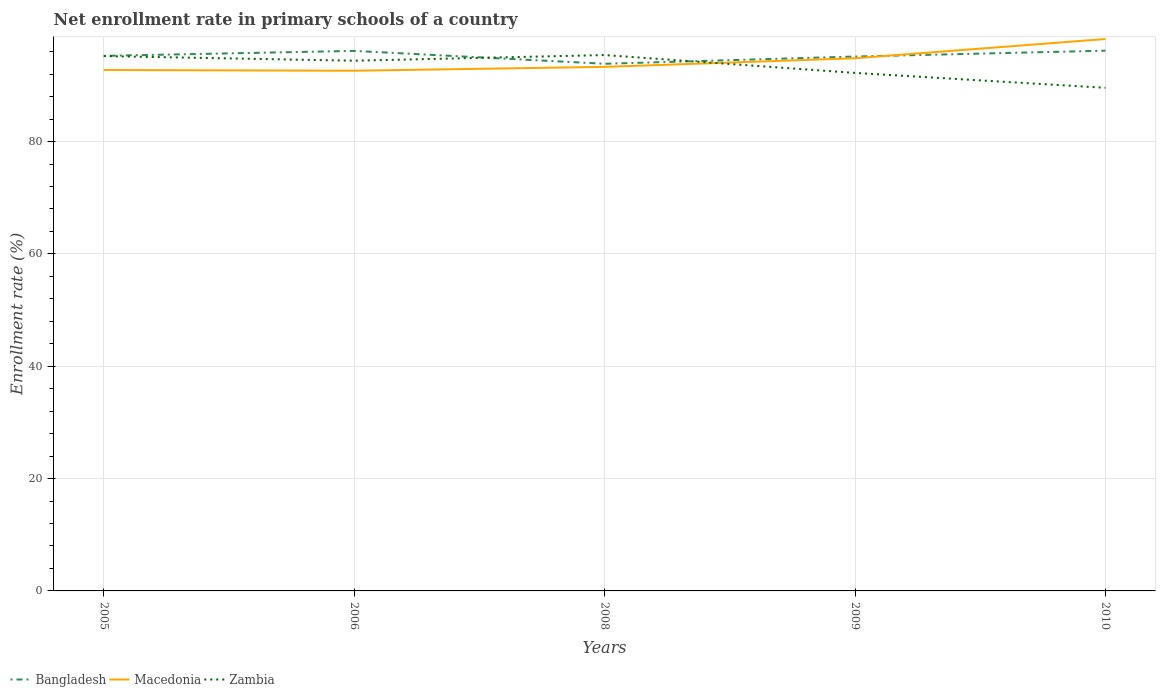Does the line corresponding to Zambia intersect with the line corresponding to Macedonia?
Make the answer very short. Yes. Is the number of lines equal to the number of legend labels?
Your answer should be compact. Yes. Across all years, what is the maximum enrollment rate in primary schools in Zambia?
Your response must be concise. 89.57. In which year was the enrollment rate in primary schools in Macedonia maximum?
Offer a terse response. 2006. What is the total enrollment rate in primary schools in Zambia in the graph?
Your answer should be very brief. 2.65. What is the difference between the highest and the second highest enrollment rate in primary schools in Bangladesh?
Make the answer very short. 2.33. Is the enrollment rate in primary schools in Bangladesh strictly greater than the enrollment rate in primary schools in Zambia over the years?
Your response must be concise. No. How many lines are there?
Provide a short and direct response. 3. How many years are there in the graph?
Give a very brief answer. 5. Are the values on the major ticks of Y-axis written in scientific E-notation?
Your answer should be very brief. No. Does the graph contain any zero values?
Ensure brevity in your answer.  No. Does the graph contain grids?
Your answer should be very brief. Yes. How are the legend labels stacked?
Your answer should be very brief. Horizontal. What is the title of the graph?
Your response must be concise. Net enrollment rate in primary schools of a country. What is the label or title of the X-axis?
Your answer should be very brief. Years. What is the label or title of the Y-axis?
Keep it short and to the point. Enrollment rate (%). What is the Enrollment rate (%) of Bangladesh in 2005?
Your response must be concise. 95.26. What is the Enrollment rate (%) of Macedonia in 2005?
Provide a short and direct response. 92.74. What is the Enrollment rate (%) of Zambia in 2005?
Give a very brief answer. 95.22. What is the Enrollment rate (%) of Bangladesh in 2006?
Your response must be concise. 96.14. What is the Enrollment rate (%) of Macedonia in 2006?
Your response must be concise. 92.61. What is the Enrollment rate (%) of Zambia in 2006?
Your response must be concise. 94.39. What is the Enrollment rate (%) in Bangladesh in 2008?
Keep it short and to the point. 93.85. What is the Enrollment rate (%) of Macedonia in 2008?
Keep it short and to the point. 93.3. What is the Enrollment rate (%) of Zambia in 2008?
Provide a short and direct response. 95.4. What is the Enrollment rate (%) of Bangladesh in 2009?
Offer a very short reply. 95.14. What is the Enrollment rate (%) in Macedonia in 2009?
Your response must be concise. 94.83. What is the Enrollment rate (%) in Zambia in 2009?
Your answer should be very brief. 92.22. What is the Enrollment rate (%) of Bangladesh in 2010?
Provide a short and direct response. 96.18. What is the Enrollment rate (%) of Macedonia in 2010?
Provide a succinct answer. 98.26. What is the Enrollment rate (%) in Zambia in 2010?
Provide a short and direct response. 89.57. Across all years, what is the maximum Enrollment rate (%) of Bangladesh?
Provide a succinct answer. 96.18. Across all years, what is the maximum Enrollment rate (%) of Macedonia?
Your answer should be compact. 98.26. Across all years, what is the maximum Enrollment rate (%) of Zambia?
Give a very brief answer. 95.4. Across all years, what is the minimum Enrollment rate (%) of Bangladesh?
Your answer should be very brief. 93.85. Across all years, what is the minimum Enrollment rate (%) in Macedonia?
Provide a succinct answer. 92.61. Across all years, what is the minimum Enrollment rate (%) in Zambia?
Keep it short and to the point. 89.57. What is the total Enrollment rate (%) of Bangladesh in the graph?
Your answer should be very brief. 476.57. What is the total Enrollment rate (%) in Macedonia in the graph?
Offer a very short reply. 471.74. What is the total Enrollment rate (%) in Zambia in the graph?
Make the answer very short. 466.8. What is the difference between the Enrollment rate (%) in Bangladesh in 2005 and that in 2006?
Keep it short and to the point. -0.89. What is the difference between the Enrollment rate (%) of Macedonia in 2005 and that in 2006?
Keep it short and to the point. 0.13. What is the difference between the Enrollment rate (%) in Zambia in 2005 and that in 2006?
Ensure brevity in your answer.  0.82. What is the difference between the Enrollment rate (%) in Bangladesh in 2005 and that in 2008?
Offer a very short reply. 1.41. What is the difference between the Enrollment rate (%) in Macedonia in 2005 and that in 2008?
Your answer should be very brief. -0.55. What is the difference between the Enrollment rate (%) in Zambia in 2005 and that in 2008?
Keep it short and to the point. -0.18. What is the difference between the Enrollment rate (%) of Bangladesh in 2005 and that in 2009?
Provide a short and direct response. 0.12. What is the difference between the Enrollment rate (%) of Macedonia in 2005 and that in 2009?
Your response must be concise. -2.09. What is the difference between the Enrollment rate (%) of Zambia in 2005 and that in 2009?
Ensure brevity in your answer.  3. What is the difference between the Enrollment rate (%) in Bangladesh in 2005 and that in 2010?
Ensure brevity in your answer.  -0.92. What is the difference between the Enrollment rate (%) of Macedonia in 2005 and that in 2010?
Give a very brief answer. -5.51. What is the difference between the Enrollment rate (%) of Zambia in 2005 and that in 2010?
Make the answer very short. 5.65. What is the difference between the Enrollment rate (%) of Bangladesh in 2006 and that in 2008?
Provide a succinct answer. 2.29. What is the difference between the Enrollment rate (%) in Macedonia in 2006 and that in 2008?
Keep it short and to the point. -0.69. What is the difference between the Enrollment rate (%) of Zambia in 2006 and that in 2008?
Your response must be concise. -1.01. What is the difference between the Enrollment rate (%) of Bangladesh in 2006 and that in 2009?
Ensure brevity in your answer.  1. What is the difference between the Enrollment rate (%) of Macedonia in 2006 and that in 2009?
Your response must be concise. -2.22. What is the difference between the Enrollment rate (%) of Zambia in 2006 and that in 2009?
Provide a short and direct response. 2.17. What is the difference between the Enrollment rate (%) in Bangladesh in 2006 and that in 2010?
Your answer should be compact. -0.04. What is the difference between the Enrollment rate (%) of Macedonia in 2006 and that in 2010?
Provide a succinct answer. -5.65. What is the difference between the Enrollment rate (%) in Zambia in 2006 and that in 2010?
Provide a short and direct response. 4.83. What is the difference between the Enrollment rate (%) in Bangladesh in 2008 and that in 2009?
Provide a succinct answer. -1.29. What is the difference between the Enrollment rate (%) of Macedonia in 2008 and that in 2009?
Give a very brief answer. -1.54. What is the difference between the Enrollment rate (%) in Zambia in 2008 and that in 2009?
Make the answer very short. 3.18. What is the difference between the Enrollment rate (%) in Bangladesh in 2008 and that in 2010?
Your answer should be very brief. -2.33. What is the difference between the Enrollment rate (%) of Macedonia in 2008 and that in 2010?
Your answer should be very brief. -4.96. What is the difference between the Enrollment rate (%) of Zambia in 2008 and that in 2010?
Make the answer very short. 5.83. What is the difference between the Enrollment rate (%) of Bangladesh in 2009 and that in 2010?
Offer a terse response. -1.04. What is the difference between the Enrollment rate (%) in Macedonia in 2009 and that in 2010?
Offer a terse response. -3.42. What is the difference between the Enrollment rate (%) of Zambia in 2009 and that in 2010?
Make the answer very short. 2.65. What is the difference between the Enrollment rate (%) of Bangladesh in 2005 and the Enrollment rate (%) of Macedonia in 2006?
Give a very brief answer. 2.65. What is the difference between the Enrollment rate (%) in Bangladesh in 2005 and the Enrollment rate (%) in Zambia in 2006?
Provide a succinct answer. 0.86. What is the difference between the Enrollment rate (%) in Macedonia in 2005 and the Enrollment rate (%) in Zambia in 2006?
Keep it short and to the point. -1.65. What is the difference between the Enrollment rate (%) in Bangladesh in 2005 and the Enrollment rate (%) in Macedonia in 2008?
Provide a short and direct response. 1.96. What is the difference between the Enrollment rate (%) in Bangladesh in 2005 and the Enrollment rate (%) in Zambia in 2008?
Provide a succinct answer. -0.14. What is the difference between the Enrollment rate (%) of Macedonia in 2005 and the Enrollment rate (%) of Zambia in 2008?
Your response must be concise. -2.66. What is the difference between the Enrollment rate (%) of Bangladesh in 2005 and the Enrollment rate (%) of Macedonia in 2009?
Provide a short and direct response. 0.43. What is the difference between the Enrollment rate (%) in Bangladesh in 2005 and the Enrollment rate (%) in Zambia in 2009?
Give a very brief answer. 3.04. What is the difference between the Enrollment rate (%) of Macedonia in 2005 and the Enrollment rate (%) of Zambia in 2009?
Your answer should be very brief. 0.52. What is the difference between the Enrollment rate (%) in Bangladesh in 2005 and the Enrollment rate (%) in Macedonia in 2010?
Your answer should be very brief. -3. What is the difference between the Enrollment rate (%) of Bangladesh in 2005 and the Enrollment rate (%) of Zambia in 2010?
Offer a terse response. 5.69. What is the difference between the Enrollment rate (%) in Macedonia in 2005 and the Enrollment rate (%) in Zambia in 2010?
Make the answer very short. 3.18. What is the difference between the Enrollment rate (%) in Bangladesh in 2006 and the Enrollment rate (%) in Macedonia in 2008?
Your response must be concise. 2.85. What is the difference between the Enrollment rate (%) in Bangladesh in 2006 and the Enrollment rate (%) in Zambia in 2008?
Give a very brief answer. 0.74. What is the difference between the Enrollment rate (%) of Macedonia in 2006 and the Enrollment rate (%) of Zambia in 2008?
Your response must be concise. -2.79. What is the difference between the Enrollment rate (%) in Bangladesh in 2006 and the Enrollment rate (%) in Macedonia in 2009?
Ensure brevity in your answer.  1.31. What is the difference between the Enrollment rate (%) in Bangladesh in 2006 and the Enrollment rate (%) in Zambia in 2009?
Keep it short and to the point. 3.92. What is the difference between the Enrollment rate (%) of Macedonia in 2006 and the Enrollment rate (%) of Zambia in 2009?
Make the answer very short. 0.39. What is the difference between the Enrollment rate (%) of Bangladesh in 2006 and the Enrollment rate (%) of Macedonia in 2010?
Make the answer very short. -2.11. What is the difference between the Enrollment rate (%) in Bangladesh in 2006 and the Enrollment rate (%) in Zambia in 2010?
Keep it short and to the point. 6.58. What is the difference between the Enrollment rate (%) of Macedonia in 2006 and the Enrollment rate (%) of Zambia in 2010?
Make the answer very short. 3.04. What is the difference between the Enrollment rate (%) of Bangladesh in 2008 and the Enrollment rate (%) of Macedonia in 2009?
Offer a terse response. -0.98. What is the difference between the Enrollment rate (%) in Bangladesh in 2008 and the Enrollment rate (%) in Zambia in 2009?
Ensure brevity in your answer.  1.63. What is the difference between the Enrollment rate (%) in Macedonia in 2008 and the Enrollment rate (%) in Zambia in 2009?
Keep it short and to the point. 1.08. What is the difference between the Enrollment rate (%) in Bangladesh in 2008 and the Enrollment rate (%) in Macedonia in 2010?
Your answer should be very brief. -4.41. What is the difference between the Enrollment rate (%) of Bangladesh in 2008 and the Enrollment rate (%) of Zambia in 2010?
Provide a succinct answer. 4.28. What is the difference between the Enrollment rate (%) of Macedonia in 2008 and the Enrollment rate (%) of Zambia in 2010?
Ensure brevity in your answer.  3.73. What is the difference between the Enrollment rate (%) in Bangladesh in 2009 and the Enrollment rate (%) in Macedonia in 2010?
Offer a very short reply. -3.12. What is the difference between the Enrollment rate (%) in Bangladesh in 2009 and the Enrollment rate (%) in Zambia in 2010?
Provide a succinct answer. 5.57. What is the difference between the Enrollment rate (%) in Macedonia in 2009 and the Enrollment rate (%) in Zambia in 2010?
Provide a short and direct response. 5.26. What is the average Enrollment rate (%) of Bangladesh per year?
Offer a very short reply. 95.31. What is the average Enrollment rate (%) of Macedonia per year?
Your response must be concise. 94.35. What is the average Enrollment rate (%) of Zambia per year?
Ensure brevity in your answer.  93.36. In the year 2005, what is the difference between the Enrollment rate (%) in Bangladesh and Enrollment rate (%) in Macedonia?
Ensure brevity in your answer.  2.51. In the year 2005, what is the difference between the Enrollment rate (%) in Bangladesh and Enrollment rate (%) in Zambia?
Offer a very short reply. 0.04. In the year 2005, what is the difference between the Enrollment rate (%) of Macedonia and Enrollment rate (%) of Zambia?
Give a very brief answer. -2.48. In the year 2006, what is the difference between the Enrollment rate (%) of Bangladesh and Enrollment rate (%) of Macedonia?
Your answer should be compact. 3.53. In the year 2006, what is the difference between the Enrollment rate (%) of Bangladesh and Enrollment rate (%) of Zambia?
Offer a terse response. 1.75. In the year 2006, what is the difference between the Enrollment rate (%) in Macedonia and Enrollment rate (%) in Zambia?
Your answer should be very brief. -1.78. In the year 2008, what is the difference between the Enrollment rate (%) in Bangladesh and Enrollment rate (%) in Macedonia?
Ensure brevity in your answer.  0.55. In the year 2008, what is the difference between the Enrollment rate (%) in Bangladesh and Enrollment rate (%) in Zambia?
Offer a very short reply. -1.55. In the year 2008, what is the difference between the Enrollment rate (%) of Macedonia and Enrollment rate (%) of Zambia?
Ensure brevity in your answer.  -2.1. In the year 2009, what is the difference between the Enrollment rate (%) of Bangladesh and Enrollment rate (%) of Macedonia?
Provide a succinct answer. 0.31. In the year 2009, what is the difference between the Enrollment rate (%) in Bangladesh and Enrollment rate (%) in Zambia?
Give a very brief answer. 2.92. In the year 2009, what is the difference between the Enrollment rate (%) in Macedonia and Enrollment rate (%) in Zambia?
Provide a short and direct response. 2.61. In the year 2010, what is the difference between the Enrollment rate (%) of Bangladesh and Enrollment rate (%) of Macedonia?
Provide a short and direct response. -2.08. In the year 2010, what is the difference between the Enrollment rate (%) of Bangladesh and Enrollment rate (%) of Zambia?
Give a very brief answer. 6.61. In the year 2010, what is the difference between the Enrollment rate (%) in Macedonia and Enrollment rate (%) in Zambia?
Give a very brief answer. 8.69. What is the ratio of the Enrollment rate (%) of Macedonia in 2005 to that in 2006?
Provide a succinct answer. 1. What is the ratio of the Enrollment rate (%) of Zambia in 2005 to that in 2006?
Your answer should be very brief. 1.01. What is the ratio of the Enrollment rate (%) of Bangladesh in 2005 to that in 2008?
Provide a succinct answer. 1.01. What is the ratio of the Enrollment rate (%) in Zambia in 2005 to that in 2008?
Your answer should be compact. 1. What is the ratio of the Enrollment rate (%) of Macedonia in 2005 to that in 2009?
Offer a terse response. 0.98. What is the ratio of the Enrollment rate (%) in Zambia in 2005 to that in 2009?
Provide a succinct answer. 1.03. What is the ratio of the Enrollment rate (%) of Bangladesh in 2005 to that in 2010?
Your answer should be compact. 0.99. What is the ratio of the Enrollment rate (%) of Macedonia in 2005 to that in 2010?
Offer a very short reply. 0.94. What is the ratio of the Enrollment rate (%) in Zambia in 2005 to that in 2010?
Offer a terse response. 1.06. What is the ratio of the Enrollment rate (%) of Bangladesh in 2006 to that in 2008?
Your answer should be very brief. 1.02. What is the ratio of the Enrollment rate (%) in Zambia in 2006 to that in 2008?
Provide a succinct answer. 0.99. What is the ratio of the Enrollment rate (%) of Bangladesh in 2006 to that in 2009?
Make the answer very short. 1.01. What is the ratio of the Enrollment rate (%) in Macedonia in 2006 to that in 2009?
Offer a terse response. 0.98. What is the ratio of the Enrollment rate (%) of Zambia in 2006 to that in 2009?
Your response must be concise. 1.02. What is the ratio of the Enrollment rate (%) of Macedonia in 2006 to that in 2010?
Keep it short and to the point. 0.94. What is the ratio of the Enrollment rate (%) of Zambia in 2006 to that in 2010?
Offer a very short reply. 1.05. What is the ratio of the Enrollment rate (%) of Bangladesh in 2008 to that in 2009?
Make the answer very short. 0.99. What is the ratio of the Enrollment rate (%) of Macedonia in 2008 to that in 2009?
Keep it short and to the point. 0.98. What is the ratio of the Enrollment rate (%) in Zambia in 2008 to that in 2009?
Ensure brevity in your answer.  1.03. What is the ratio of the Enrollment rate (%) of Bangladesh in 2008 to that in 2010?
Offer a very short reply. 0.98. What is the ratio of the Enrollment rate (%) in Macedonia in 2008 to that in 2010?
Give a very brief answer. 0.95. What is the ratio of the Enrollment rate (%) of Zambia in 2008 to that in 2010?
Your answer should be compact. 1.07. What is the ratio of the Enrollment rate (%) of Bangladesh in 2009 to that in 2010?
Make the answer very short. 0.99. What is the ratio of the Enrollment rate (%) of Macedonia in 2009 to that in 2010?
Your answer should be compact. 0.97. What is the ratio of the Enrollment rate (%) of Zambia in 2009 to that in 2010?
Offer a terse response. 1.03. What is the difference between the highest and the second highest Enrollment rate (%) in Bangladesh?
Your response must be concise. 0.04. What is the difference between the highest and the second highest Enrollment rate (%) in Macedonia?
Give a very brief answer. 3.42. What is the difference between the highest and the second highest Enrollment rate (%) in Zambia?
Offer a very short reply. 0.18. What is the difference between the highest and the lowest Enrollment rate (%) of Bangladesh?
Your response must be concise. 2.33. What is the difference between the highest and the lowest Enrollment rate (%) of Macedonia?
Offer a very short reply. 5.65. What is the difference between the highest and the lowest Enrollment rate (%) in Zambia?
Your response must be concise. 5.83. 